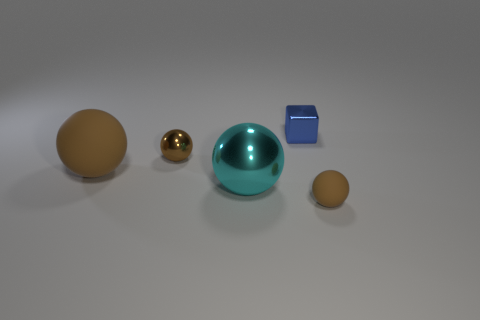How might the objects' colors influence a viewer's interpretation of this scene? The use of colors can convey various emotions or themes. For instance, the teal sphere's vibrant hue draws attention and could evoke feelings of tranquility or curiosity, while the golden sphere might be seen as precious or important. The muted tan of the spheres offers a comforting, grounded effect, and the blue cube's saturation can give a sense of stability or trustworthiness.  Imagine these objects are used in a storytelling context. Could you craft a brief narrative involving them? In a distant miniature universe, the grand teal sphere reigns as the benevolent guardian of harmony. The golden orb is a treasured source of knowledge, sought after by the inhabitants of the tan planets. The small, yet significant blue cube is the key to unraveling the universe's deepest mysteries, possessing the power to bridge worlds. Together, they form elements of a tale that intertwines destiny and discovery. 